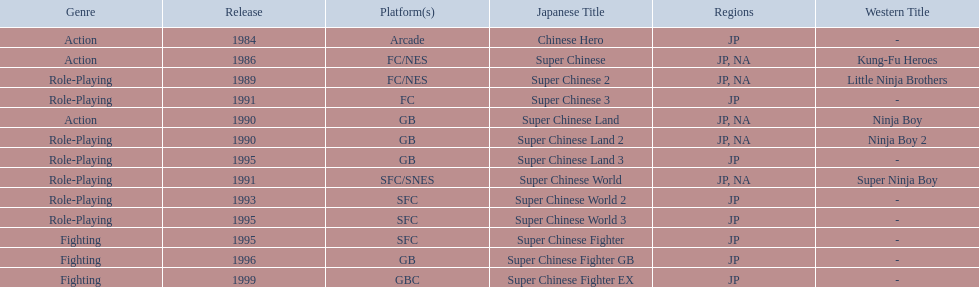What japanese titles were released in the north american (na) region? Super Chinese, Super Chinese 2, Super Chinese Land, Super Chinese Land 2, Super Chinese World. Of those, which one was released most recently? Super Chinese World. 